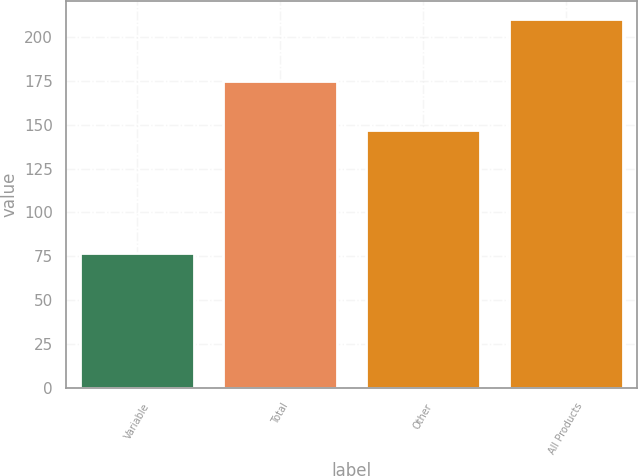Convert chart. <chart><loc_0><loc_0><loc_500><loc_500><bar_chart><fcel>Variable<fcel>Total<fcel>Other<fcel>All Products<nl><fcel>77<fcel>175<fcel>147<fcel>210<nl></chart> 